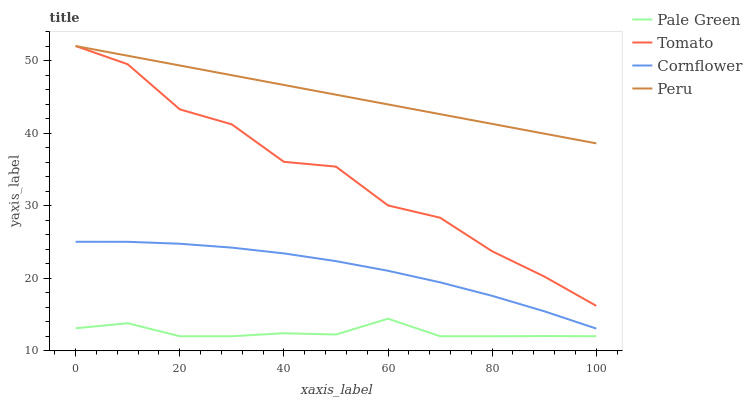Does Pale Green have the minimum area under the curve?
Answer yes or no. Yes. Does Peru have the maximum area under the curve?
Answer yes or no. Yes. Does Cornflower have the minimum area under the curve?
Answer yes or no. No. Does Cornflower have the maximum area under the curve?
Answer yes or no. No. Is Peru the smoothest?
Answer yes or no. Yes. Is Tomato the roughest?
Answer yes or no. Yes. Is Cornflower the smoothest?
Answer yes or no. No. Is Cornflower the roughest?
Answer yes or no. No. Does Pale Green have the lowest value?
Answer yes or no. Yes. Does Cornflower have the lowest value?
Answer yes or no. No. Does Peru have the highest value?
Answer yes or no. Yes. Does Cornflower have the highest value?
Answer yes or no. No. Is Pale Green less than Tomato?
Answer yes or no. Yes. Is Tomato greater than Pale Green?
Answer yes or no. Yes. Does Peru intersect Tomato?
Answer yes or no. Yes. Is Peru less than Tomato?
Answer yes or no. No. Is Peru greater than Tomato?
Answer yes or no. No. Does Pale Green intersect Tomato?
Answer yes or no. No. 